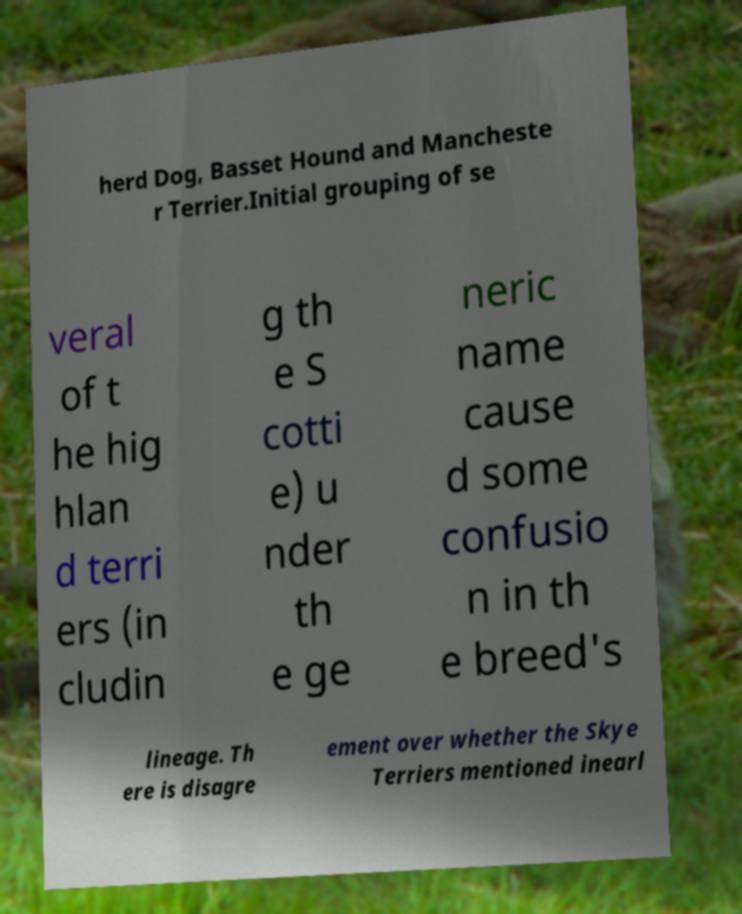There's text embedded in this image that I need extracted. Can you transcribe it verbatim? herd Dog, Basset Hound and Mancheste r Terrier.Initial grouping of se veral of t he hig hlan d terri ers (in cludin g th e S cotti e) u nder th e ge neric name cause d some confusio n in th e breed's lineage. Th ere is disagre ement over whether the Skye Terriers mentioned inearl 